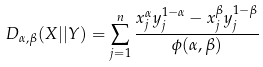Convert formula to latex. <formula><loc_0><loc_0><loc_500><loc_500>D _ { \alpha , \beta } ( X | | Y ) = \sum _ { j = 1 } ^ { n } \frac { x _ { j } ^ { \alpha } y _ { j } ^ { 1 - \alpha } - x _ { j } ^ { \beta } y _ { j } ^ { 1 - \beta } } { \phi ( \alpha , \beta ) }</formula> 